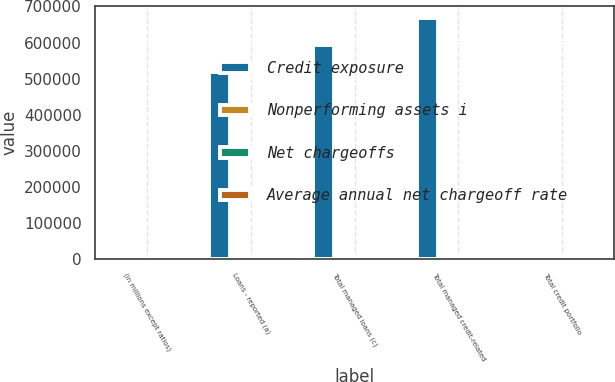<chart> <loc_0><loc_0><loc_500><loc_500><stacked_bar_chart><ecel><fcel>(in millions except ratios)<fcel>Loans - reported (a)<fcel>Total managed loans (c)<fcel>Total managed credit-related<fcel>Total credit portfolio<nl><fcel>Credit exposure<fcel>2007<fcel>519374<fcel>592075<fcel>669211<fcel>3586<nl><fcel>Nonperforming assets i<fcel>2007<fcel>3586<fcel>3586<fcel>3615<fcel>4237<nl><fcel>Net chargeoffs<fcel>2007<fcel>4538<fcel>6918<fcel>6918<fcel>6918<nl><fcel>Average annual net chargeoff rate<fcel>2007<fcel>1<fcel>1.33<fcel>1.33<fcel>1.33<nl></chart> 